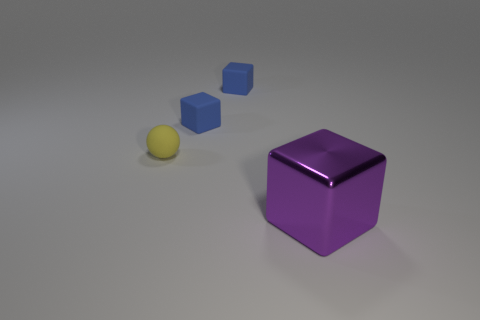What might be the purpose of arranging these objects as they are in the image? The arrangement of these objects could be for several purposes. It might be a simple display for a visual composition highlighting contrasts in color, size, and shape. Alternatively, it could be an educational setup to demonstrate the concept of perspective or geometry to students. The exact intent may depend on the context in which this image was taken or used. 